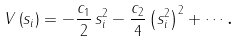<formula> <loc_0><loc_0><loc_500><loc_500>V \left ( { s } _ { i } \right ) = - \frac { c _ { 1 } } 2 \, { s } _ { i } ^ { 2 } - \frac { c _ { 2 } } 4 \left ( { s } _ { i } ^ { 2 } \right ) ^ { 2 } + \cdots \text {.}</formula> 